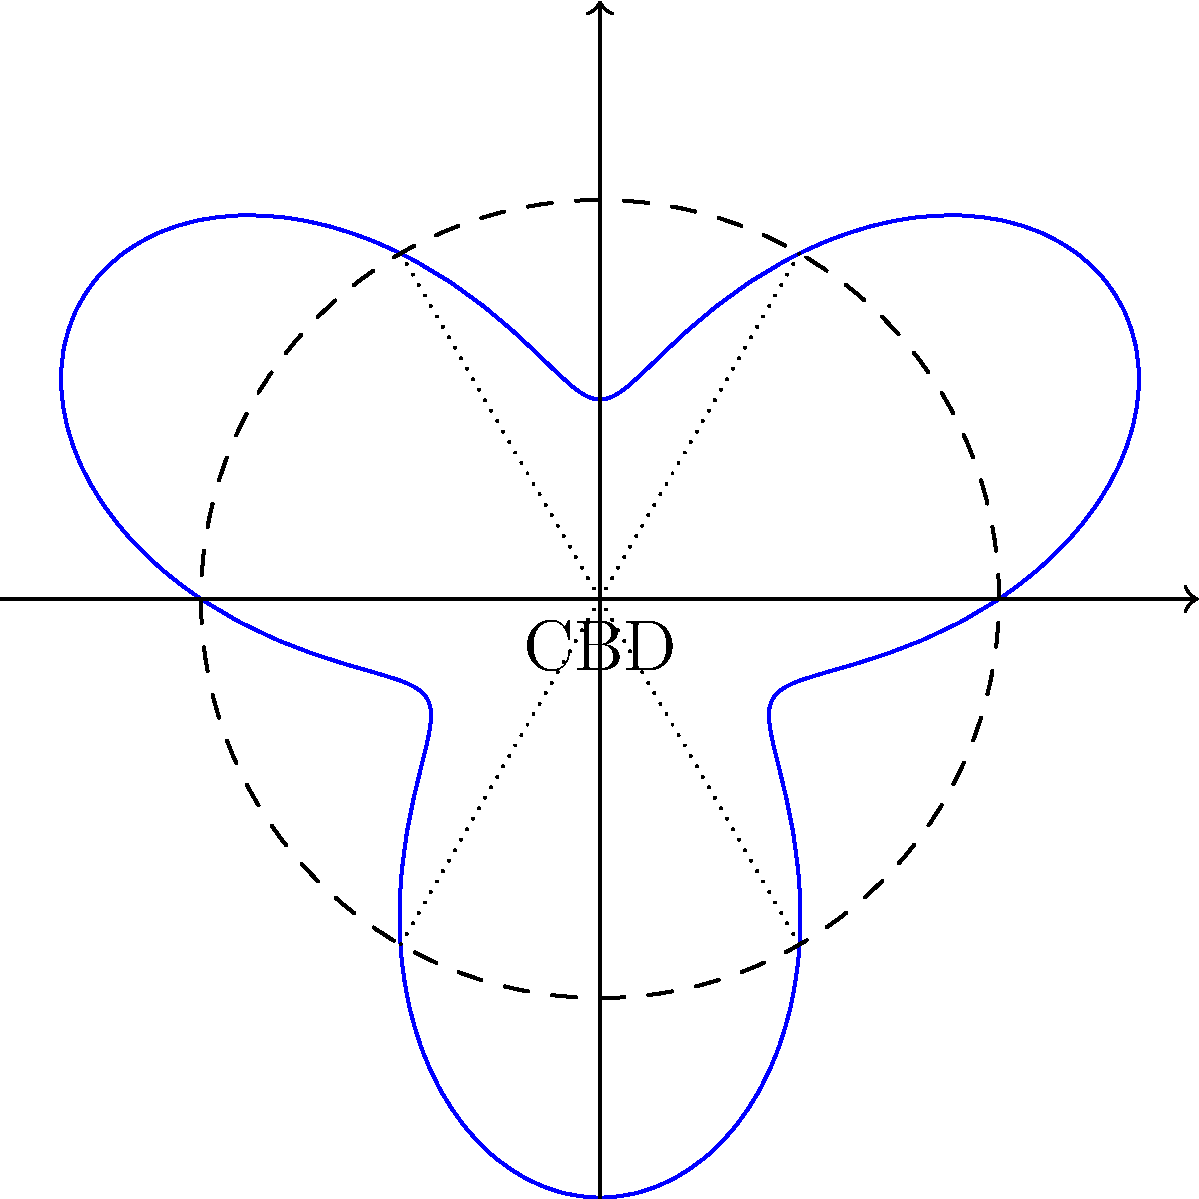The circular layout of Sydney's Central Business District (CBD) can be represented using polar coordinates. The boundary of the CBD is described by the equation $r = 2 + \sin(3\theta)$, where $r$ is in kilometers. Calculate the total area of the CBD. To find the area enclosed by a polar curve, we use the formula:

$$A = \frac{1}{2} \int_{0}^{2\pi} r^2(\theta) d\theta$$

For our curve, $r(\theta) = 2 + \sin(3\theta)$. Let's solve this step-by-step:

1) First, we need to square $r(\theta)$:
   $r^2(\theta) = (2 + \sin(3\theta))^2 = 4 + 4\sin(3\theta) + \sin^2(3\theta)$

2) Now, we set up the integral:
   $$A = \frac{1}{2} \int_{0}^{2\pi} (4 + 4\sin(3\theta) + \sin^2(3\theta)) d\theta$$

3) Let's integrate each term separately:
   a) $\int_{0}^{2\pi} 4 d\theta = 4\theta \big|_{0}^{2\pi} = 8\pi$
   
   b) $\int_{0}^{2\pi} 4\sin(3\theta) d\theta = -\frac{4}{3}\cos(3\theta) \big|_{0}^{2\pi} = 0$
   
   c) For $\int_{0}^{2\pi} \sin^2(3\theta) d\theta$, we use the identity $\sin^2 x = \frac{1-\cos(2x)}{2}$:
      $\int_{0}^{2\pi} \sin^2(3\theta) d\theta = \int_{0}^{2\pi} \frac{1-\cos(6\theta)}{2} d\theta$
      $= \frac{1}{2}\theta - \frac{1}{12}\sin(6\theta) \big|_{0}^{2\pi} = \pi$

4) Adding these results:
   $A = \frac{1}{2} (8\pi + 0 + \pi) = \frac{9\pi}{2}$

Therefore, the total area of the CBD is $\frac{9\pi}{2}$ square kilometers.
Answer: $\frac{9\pi}{2}$ km² 